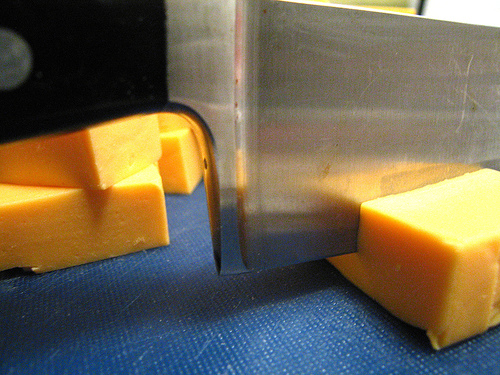<image>
Is there a knife above the table? Yes. The knife is positioned above the table in the vertical space, higher up in the scene. 